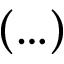Convert formula to latex. <formula><loc_0><loc_0><loc_500><loc_500>( \dots )</formula> 